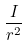<formula> <loc_0><loc_0><loc_500><loc_500>\frac { I } { r ^ { 2 } }</formula> 